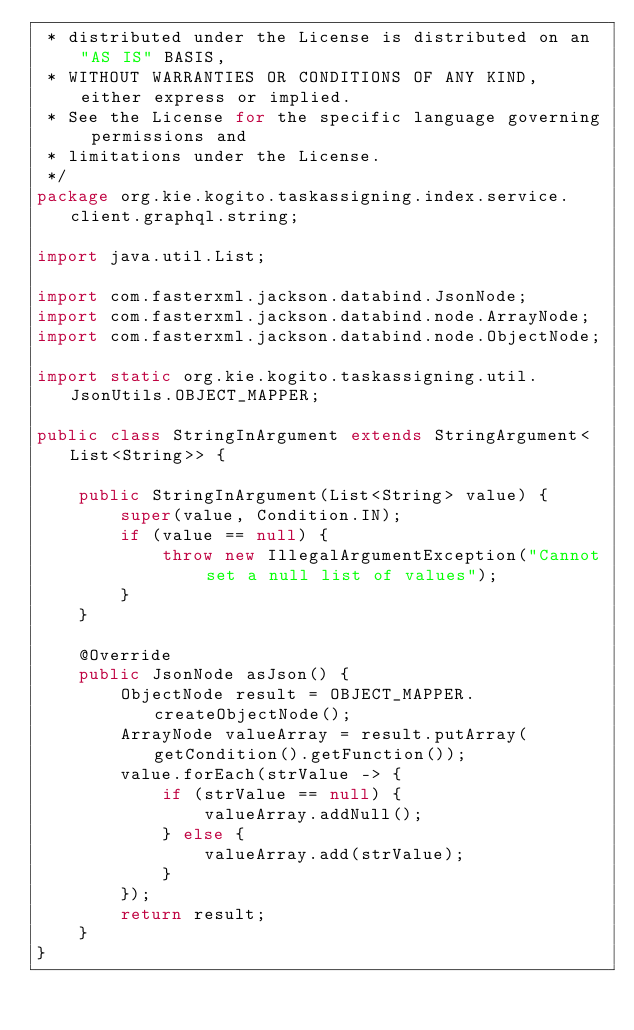<code> <loc_0><loc_0><loc_500><loc_500><_Java_> * distributed under the License is distributed on an "AS IS" BASIS,
 * WITHOUT WARRANTIES OR CONDITIONS OF ANY KIND, either express or implied.
 * See the License for the specific language governing permissions and
 * limitations under the License.
 */
package org.kie.kogito.taskassigning.index.service.client.graphql.string;

import java.util.List;

import com.fasterxml.jackson.databind.JsonNode;
import com.fasterxml.jackson.databind.node.ArrayNode;
import com.fasterxml.jackson.databind.node.ObjectNode;

import static org.kie.kogito.taskassigning.util.JsonUtils.OBJECT_MAPPER;

public class StringInArgument extends StringArgument<List<String>> {

    public StringInArgument(List<String> value) {
        super(value, Condition.IN);
        if (value == null) {
            throw new IllegalArgumentException("Cannot set a null list of values");
        }
    }

    @Override
    public JsonNode asJson() {
        ObjectNode result = OBJECT_MAPPER.createObjectNode();
        ArrayNode valueArray = result.putArray(getCondition().getFunction());
        value.forEach(strValue -> {
            if (strValue == null) {
                valueArray.addNull();
            } else {
                valueArray.add(strValue);
            }
        });
        return result;
    }
}
</code> 